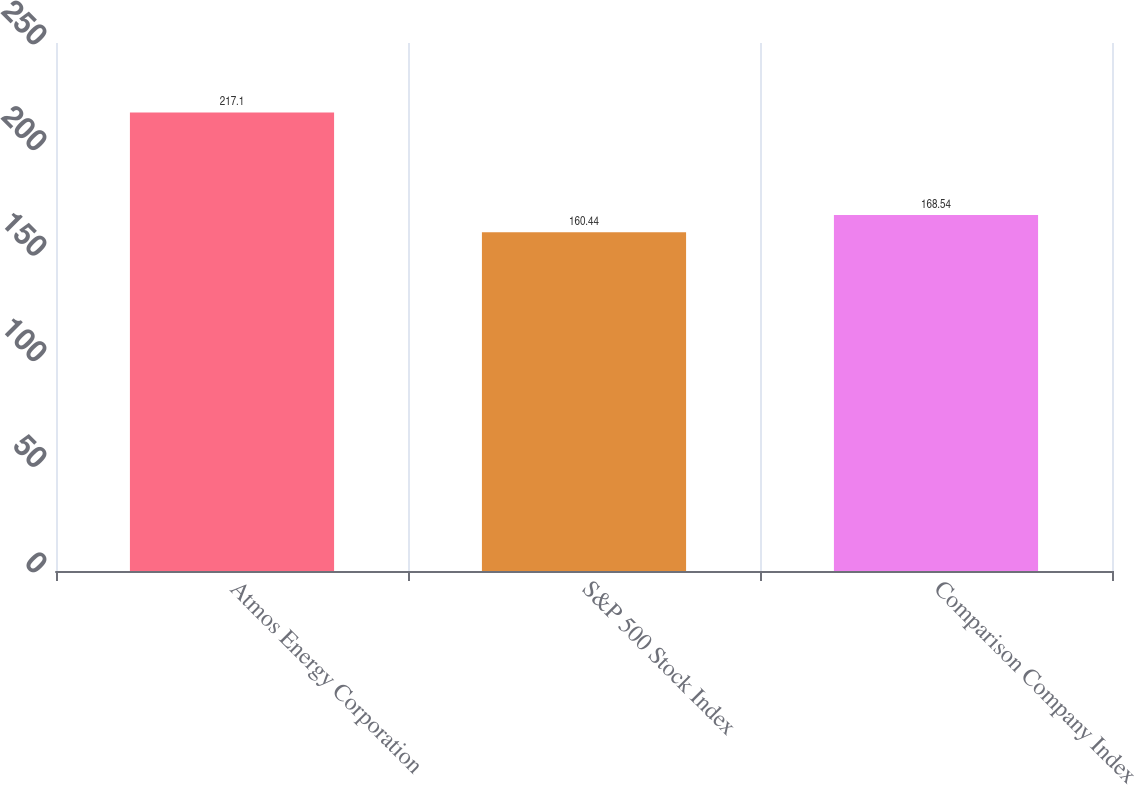<chart> <loc_0><loc_0><loc_500><loc_500><bar_chart><fcel>Atmos Energy Corporation<fcel>S&P 500 Stock Index<fcel>Comparison Company Index<nl><fcel>217.1<fcel>160.44<fcel>168.54<nl></chart> 